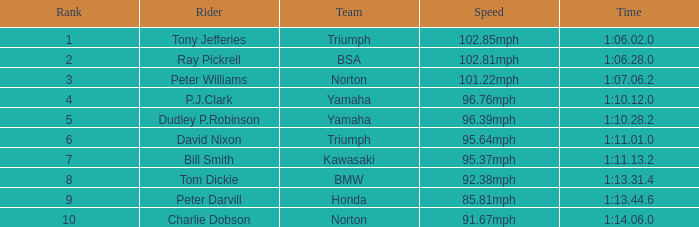Traveling at 9 1:10.12.0. 